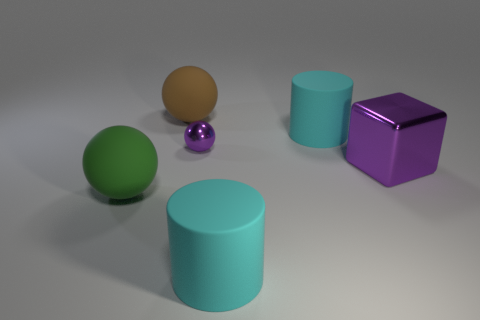Add 1 big purple shiny blocks. How many objects exist? 7 Subtract all cylinders. How many objects are left? 4 Subtract all big brown objects. Subtract all green spheres. How many objects are left? 4 Add 6 big cylinders. How many big cylinders are left? 8 Add 2 large cyan cylinders. How many large cyan cylinders exist? 4 Subtract 0 gray balls. How many objects are left? 6 